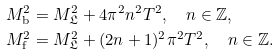<formula> <loc_0><loc_0><loc_500><loc_500>M ^ { 2 } _ { \mathrm b } & = M ^ { 2 } _ { \mathfrak L } + 4 \pi ^ { 2 } n ^ { 2 } T ^ { 2 } , \quad n \in \mathbb { Z } , \\ M ^ { 2 } _ { \mathrm f } & = M ^ { 2 } _ { \mathfrak L } + ( 2 n + 1 ) ^ { 2 } \pi ^ { 2 } T ^ { 2 } , \quad n \in \mathbb { Z } .</formula> 